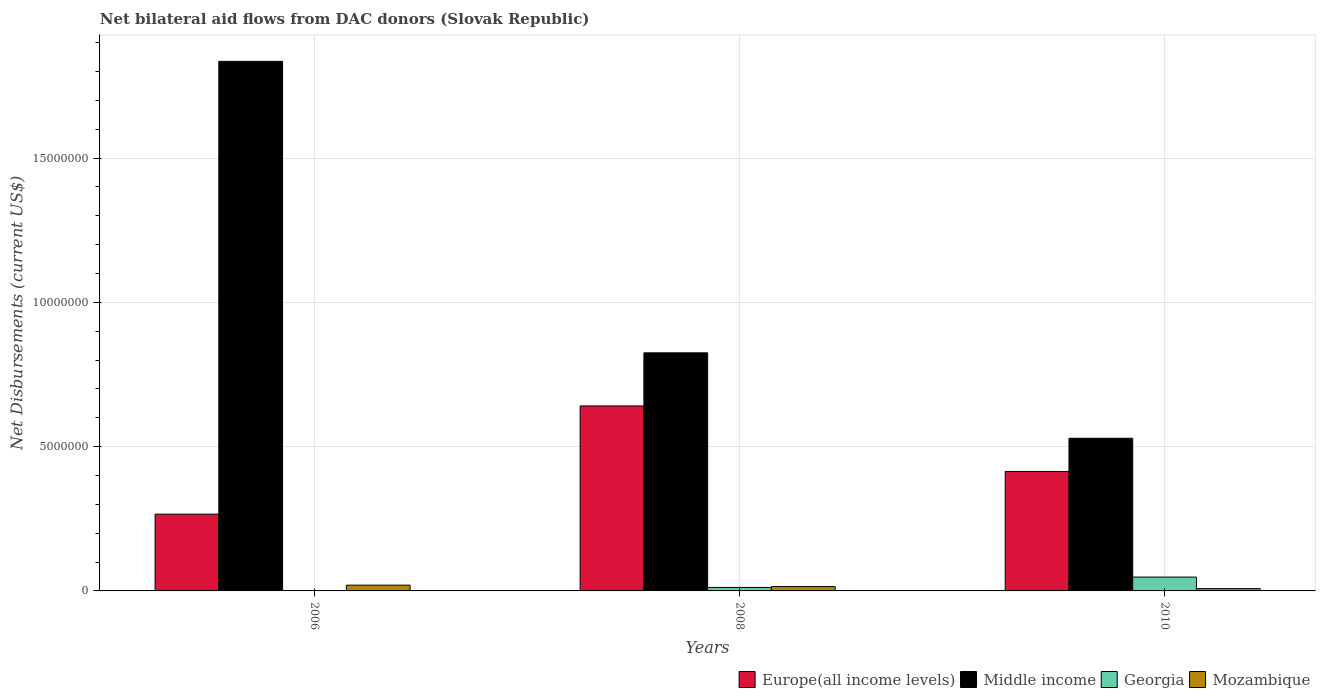How many different coloured bars are there?
Provide a succinct answer. 4. How many groups of bars are there?
Your answer should be compact. 3. Are the number of bars on each tick of the X-axis equal?
Give a very brief answer. Yes. How many bars are there on the 1st tick from the right?
Keep it short and to the point. 4. In how many cases, is the number of bars for a given year not equal to the number of legend labels?
Offer a terse response. 0. Across all years, what is the maximum net bilateral aid flows in Middle income?
Provide a short and direct response. 1.84e+07. Across all years, what is the minimum net bilateral aid flows in Europe(all income levels)?
Your response must be concise. 2.66e+06. In which year was the net bilateral aid flows in Georgia maximum?
Give a very brief answer. 2010. What is the total net bilateral aid flows in Europe(all income levels) in the graph?
Your response must be concise. 1.32e+07. What is the difference between the net bilateral aid flows in Middle income in 2010 and the net bilateral aid flows in Mozambique in 2006?
Your response must be concise. 5.09e+06. What is the average net bilateral aid flows in Middle income per year?
Ensure brevity in your answer.  1.06e+07. What is the ratio of the net bilateral aid flows in Europe(all income levels) in 2006 to that in 2008?
Give a very brief answer. 0.41. What is the difference between the highest and the second highest net bilateral aid flows in Middle income?
Offer a very short reply. 1.01e+07. What is the difference between the highest and the lowest net bilateral aid flows in Middle income?
Your answer should be compact. 1.31e+07. What does the 4th bar from the right in 2010 represents?
Keep it short and to the point. Europe(all income levels). Is it the case that in every year, the sum of the net bilateral aid flows in Europe(all income levels) and net bilateral aid flows in Mozambique is greater than the net bilateral aid flows in Middle income?
Keep it short and to the point. No. Are all the bars in the graph horizontal?
Your answer should be compact. No. How many years are there in the graph?
Make the answer very short. 3. Does the graph contain any zero values?
Keep it short and to the point. No. Does the graph contain grids?
Make the answer very short. Yes. How many legend labels are there?
Provide a short and direct response. 4. How are the legend labels stacked?
Give a very brief answer. Horizontal. What is the title of the graph?
Ensure brevity in your answer.  Net bilateral aid flows from DAC donors (Slovak Republic). What is the label or title of the X-axis?
Your response must be concise. Years. What is the label or title of the Y-axis?
Keep it short and to the point. Net Disbursements (current US$). What is the Net Disbursements (current US$) in Europe(all income levels) in 2006?
Give a very brief answer. 2.66e+06. What is the Net Disbursements (current US$) of Middle income in 2006?
Make the answer very short. 1.84e+07. What is the Net Disbursements (current US$) of Europe(all income levels) in 2008?
Make the answer very short. 6.41e+06. What is the Net Disbursements (current US$) in Middle income in 2008?
Your answer should be compact. 8.25e+06. What is the Net Disbursements (current US$) of Georgia in 2008?
Your response must be concise. 1.20e+05. What is the Net Disbursements (current US$) of Mozambique in 2008?
Give a very brief answer. 1.50e+05. What is the Net Disbursements (current US$) in Europe(all income levels) in 2010?
Give a very brief answer. 4.14e+06. What is the Net Disbursements (current US$) of Middle income in 2010?
Keep it short and to the point. 5.29e+06. What is the Net Disbursements (current US$) of Georgia in 2010?
Ensure brevity in your answer.  4.80e+05. Across all years, what is the maximum Net Disbursements (current US$) in Europe(all income levels)?
Offer a very short reply. 6.41e+06. Across all years, what is the maximum Net Disbursements (current US$) in Middle income?
Provide a succinct answer. 1.84e+07. Across all years, what is the minimum Net Disbursements (current US$) in Europe(all income levels)?
Make the answer very short. 2.66e+06. Across all years, what is the minimum Net Disbursements (current US$) of Middle income?
Provide a short and direct response. 5.29e+06. What is the total Net Disbursements (current US$) of Europe(all income levels) in the graph?
Make the answer very short. 1.32e+07. What is the total Net Disbursements (current US$) of Middle income in the graph?
Provide a succinct answer. 3.19e+07. What is the difference between the Net Disbursements (current US$) of Europe(all income levels) in 2006 and that in 2008?
Ensure brevity in your answer.  -3.75e+06. What is the difference between the Net Disbursements (current US$) in Middle income in 2006 and that in 2008?
Keep it short and to the point. 1.01e+07. What is the difference between the Net Disbursements (current US$) in Georgia in 2006 and that in 2008?
Offer a very short reply. -1.10e+05. What is the difference between the Net Disbursements (current US$) in Europe(all income levels) in 2006 and that in 2010?
Provide a succinct answer. -1.48e+06. What is the difference between the Net Disbursements (current US$) in Middle income in 2006 and that in 2010?
Your answer should be compact. 1.31e+07. What is the difference between the Net Disbursements (current US$) in Georgia in 2006 and that in 2010?
Provide a succinct answer. -4.70e+05. What is the difference between the Net Disbursements (current US$) in Europe(all income levels) in 2008 and that in 2010?
Give a very brief answer. 2.27e+06. What is the difference between the Net Disbursements (current US$) of Middle income in 2008 and that in 2010?
Provide a short and direct response. 2.96e+06. What is the difference between the Net Disbursements (current US$) of Georgia in 2008 and that in 2010?
Offer a terse response. -3.60e+05. What is the difference between the Net Disbursements (current US$) in Mozambique in 2008 and that in 2010?
Your answer should be very brief. 7.00e+04. What is the difference between the Net Disbursements (current US$) in Europe(all income levels) in 2006 and the Net Disbursements (current US$) in Middle income in 2008?
Ensure brevity in your answer.  -5.59e+06. What is the difference between the Net Disbursements (current US$) in Europe(all income levels) in 2006 and the Net Disbursements (current US$) in Georgia in 2008?
Your response must be concise. 2.54e+06. What is the difference between the Net Disbursements (current US$) of Europe(all income levels) in 2006 and the Net Disbursements (current US$) of Mozambique in 2008?
Keep it short and to the point. 2.51e+06. What is the difference between the Net Disbursements (current US$) in Middle income in 2006 and the Net Disbursements (current US$) in Georgia in 2008?
Provide a succinct answer. 1.82e+07. What is the difference between the Net Disbursements (current US$) of Middle income in 2006 and the Net Disbursements (current US$) of Mozambique in 2008?
Offer a very short reply. 1.82e+07. What is the difference between the Net Disbursements (current US$) of Georgia in 2006 and the Net Disbursements (current US$) of Mozambique in 2008?
Keep it short and to the point. -1.40e+05. What is the difference between the Net Disbursements (current US$) of Europe(all income levels) in 2006 and the Net Disbursements (current US$) of Middle income in 2010?
Your answer should be compact. -2.63e+06. What is the difference between the Net Disbursements (current US$) of Europe(all income levels) in 2006 and the Net Disbursements (current US$) of Georgia in 2010?
Offer a very short reply. 2.18e+06. What is the difference between the Net Disbursements (current US$) in Europe(all income levels) in 2006 and the Net Disbursements (current US$) in Mozambique in 2010?
Make the answer very short. 2.58e+06. What is the difference between the Net Disbursements (current US$) of Middle income in 2006 and the Net Disbursements (current US$) of Georgia in 2010?
Provide a succinct answer. 1.79e+07. What is the difference between the Net Disbursements (current US$) in Middle income in 2006 and the Net Disbursements (current US$) in Mozambique in 2010?
Your response must be concise. 1.83e+07. What is the difference between the Net Disbursements (current US$) of Georgia in 2006 and the Net Disbursements (current US$) of Mozambique in 2010?
Keep it short and to the point. -7.00e+04. What is the difference between the Net Disbursements (current US$) of Europe(all income levels) in 2008 and the Net Disbursements (current US$) of Middle income in 2010?
Make the answer very short. 1.12e+06. What is the difference between the Net Disbursements (current US$) in Europe(all income levels) in 2008 and the Net Disbursements (current US$) in Georgia in 2010?
Make the answer very short. 5.93e+06. What is the difference between the Net Disbursements (current US$) of Europe(all income levels) in 2008 and the Net Disbursements (current US$) of Mozambique in 2010?
Make the answer very short. 6.33e+06. What is the difference between the Net Disbursements (current US$) in Middle income in 2008 and the Net Disbursements (current US$) in Georgia in 2010?
Give a very brief answer. 7.77e+06. What is the difference between the Net Disbursements (current US$) in Middle income in 2008 and the Net Disbursements (current US$) in Mozambique in 2010?
Provide a succinct answer. 8.17e+06. What is the difference between the Net Disbursements (current US$) of Georgia in 2008 and the Net Disbursements (current US$) of Mozambique in 2010?
Make the answer very short. 4.00e+04. What is the average Net Disbursements (current US$) of Europe(all income levels) per year?
Provide a succinct answer. 4.40e+06. What is the average Net Disbursements (current US$) in Middle income per year?
Your response must be concise. 1.06e+07. What is the average Net Disbursements (current US$) in Georgia per year?
Your answer should be very brief. 2.03e+05. What is the average Net Disbursements (current US$) of Mozambique per year?
Provide a succinct answer. 1.43e+05. In the year 2006, what is the difference between the Net Disbursements (current US$) of Europe(all income levels) and Net Disbursements (current US$) of Middle income?
Your answer should be very brief. -1.57e+07. In the year 2006, what is the difference between the Net Disbursements (current US$) in Europe(all income levels) and Net Disbursements (current US$) in Georgia?
Keep it short and to the point. 2.65e+06. In the year 2006, what is the difference between the Net Disbursements (current US$) in Europe(all income levels) and Net Disbursements (current US$) in Mozambique?
Ensure brevity in your answer.  2.46e+06. In the year 2006, what is the difference between the Net Disbursements (current US$) in Middle income and Net Disbursements (current US$) in Georgia?
Your response must be concise. 1.83e+07. In the year 2006, what is the difference between the Net Disbursements (current US$) in Middle income and Net Disbursements (current US$) in Mozambique?
Ensure brevity in your answer.  1.82e+07. In the year 2006, what is the difference between the Net Disbursements (current US$) in Georgia and Net Disbursements (current US$) in Mozambique?
Make the answer very short. -1.90e+05. In the year 2008, what is the difference between the Net Disbursements (current US$) in Europe(all income levels) and Net Disbursements (current US$) in Middle income?
Provide a short and direct response. -1.84e+06. In the year 2008, what is the difference between the Net Disbursements (current US$) of Europe(all income levels) and Net Disbursements (current US$) of Georgia?
Offer a terse response. 6.29e+06. In the year 2008, what is the difference between the Net Disbursements (current US$) in Europe(all income levels) and Net Disbursements (current US$) in Mozambique?
Keep it short and to the point. 6.26e+06. In the year 2008, what is the difference between the Net Disbursements (current US$) in Middle income and Net Disbursements (current US$) in Georgia?
Provide a short and direct response. 8.13e+06. In the year 2008, what is the difference between the Net Disbursements (current US$) of Middle income and Net Disbursements (current US$) of Mozambique?
Provide a succinct answer. 8.10e+06. In the year 2008, what is the difference between the Net Disbursements (current US$) of Georgia and Net Disbursements (current US$) of Mozambique?
Provide a succinct answer. -3.00e+04. In the year 2010, what is the difference between the Net Disbursements (current US$) in Europe(all income levels) and Net Disbursements (current US$) in Middle income?
Your response must be concise. -1.15e+06. In the year 2010, what is the difference between the Net Disbursements (current US$) of Europe(all income levels) and Net Disbursements (current US$) of Georgia?
Give a very brief answer. 3.66e+06. In the year 2010, what is the difference between the Net Disbursements (current US$) in Europe(all income levels) and Net Disbursements (current US$) in Mozambique?
Keep it short and to the point. 4.06e+06. In the year 2010, what is the difference between the Net Disbursements (current US$) in Middle income and Net Disbursements (current US$) in Georgia?
Your response must be concise. 4.81e+06. In the year 2010, what is the difference between the Net Disbursements (current US$) in Middle income and Net Disbursements (current US$) in Mozambique?
Offer a very short reply. 5.21e+06. In the year 2010, what is the difference between the Net Disbursements (current US$) of Georgia and Net Disbursements (current US$) of Mozambique?
Give a very brief answer. 4.00e+05. What is the ratio of the Net Disbursements (current US$) of Europe(all income levels) in 2006 to that in 2008?
Your answer should be very brief. 0.41. What is the ratio of the Net Disbursements (current US$) of Middle income in 2006 to that in 2008?
Offer a very short reply. 2.22. What is the ratio of the Net Disbursements (current US$) in Georgia in 2006 to that in 2008?
Offer a terse response. 0.08. What is the ratio of the Net Disbursements (current US$) in Mozambique in 2006 to that in 2008?
Your answer should be very brief. 1.33. What is the ratio of the Net Disbursements (current US$) of Europe(all income levels) in 2006 to that in 2010?
Your answer should be very brief. 0.64. What is the ratio of the Net Disbursements (current US$) in Middle income in 2006 to that in 2010?
Keep it short and to the point. 3.47. What is the ratio of the Net Disbursements (current US$) of Georgia in 2006 to that in 2010?
Give a very brief answer. 0.02. What is the ratio of the Net Disbursements (current US$) in Europe(all income levels) in 2008 to that in 2010?
Keep it short and to the point. 1.55. What is the ratio of the Net Disbursements (current US$) in Middle income in 2008 to that in 2010?
Make the answer very short. 1.56. What is the ratio of the Net Disbursements (current US$) in Mozambique in 2008 to that in 2010?
Ensure brevity in your answer.  1.88. What is the difference between the highest and the second highest Net Disbursements (current US$) of Europe(all income levels)?
Give a very brief answer. 2.27e+06. What is the difference between the highest and the second highest Net Disbursements (current US$) in Middle income?
Your answer should be compact. 1.01e+07. What is the difference between the highest and the second highest Net Disbursements (current US$) of Mozambique?
Make the answer very short. 5.00e+04. What is the difference between the highest and the lowest Net Disbursements (current US$) of Europe(all income levels)?
Your response must be concise. 3.75e+06. What is the difference between the highest and the lowest Net Disbursements (current US$) of Middle income?
Your answer should be compact. 1.31e+07. What is the difference between the highest and the lowest Net Disbursements (current US$) of Georgia?
Give a very brief answer. 4.70e+05. 